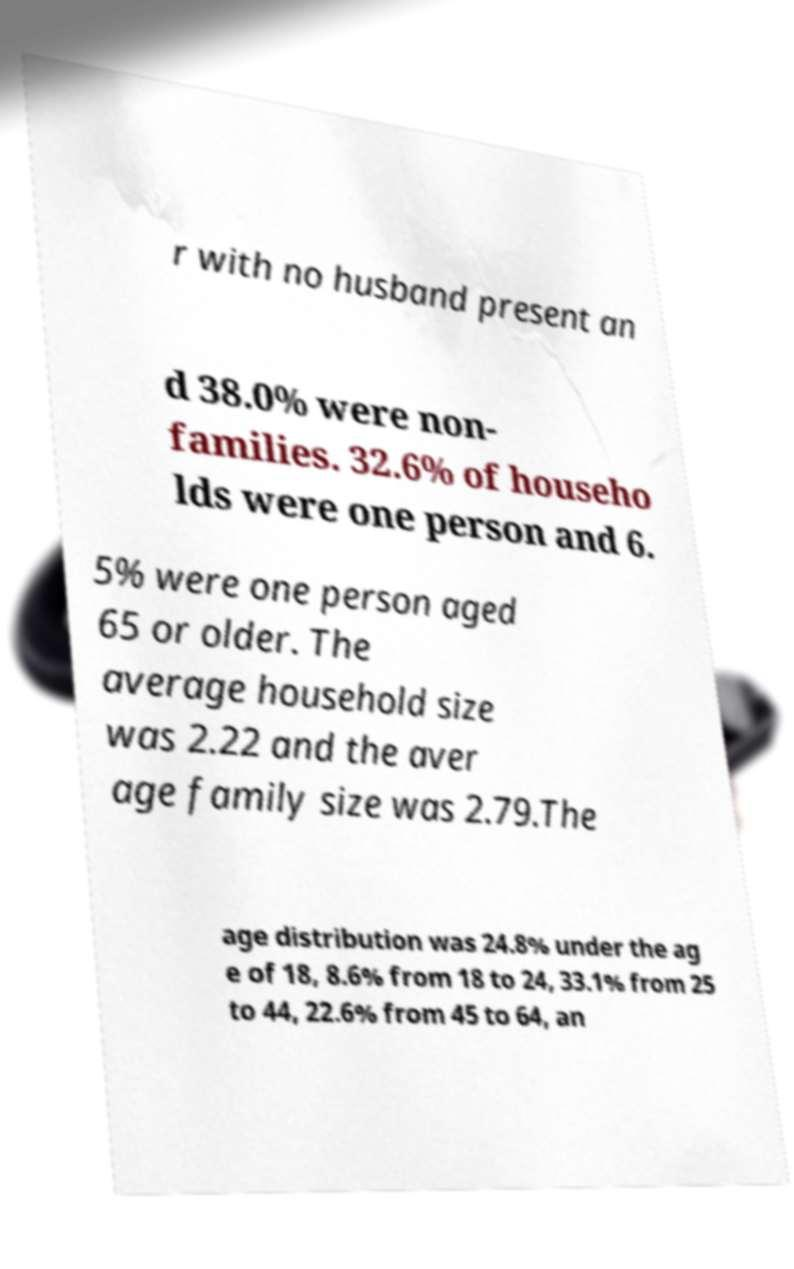I need the written content from this picture converted into text. Can you do that? r with no husband present an d 38.0% were non- families. 32.6% of househo lds were one person and 6. 5% were one person aged 65 or older. The average household size was 2.22 and the aver age family size was 2.79.The age distribution was 24.8% under the ag e of 18, 8.6% from 18 to 24, 33.1% from 25 to 44, 22.6% from 45 to 64, an 